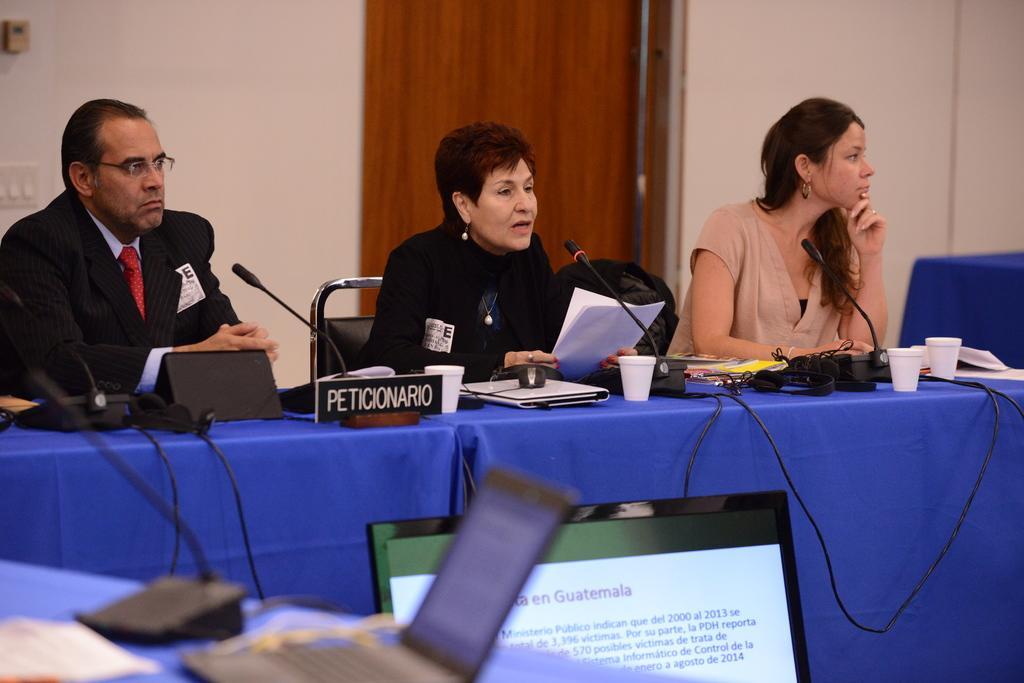In one or two sentences, can you explain what this image depicts? In the bottom left corner of the image there is a table with mics, laptop and paper. Behind the table there is a screen with something on it. Behind the screen there is a table with name boards, cups, mics and some other things on it. Behind the table on the left side there is a man sitting and he kept spectacles. And there are two ladies sitting. Behind them there is a wall with a door. 